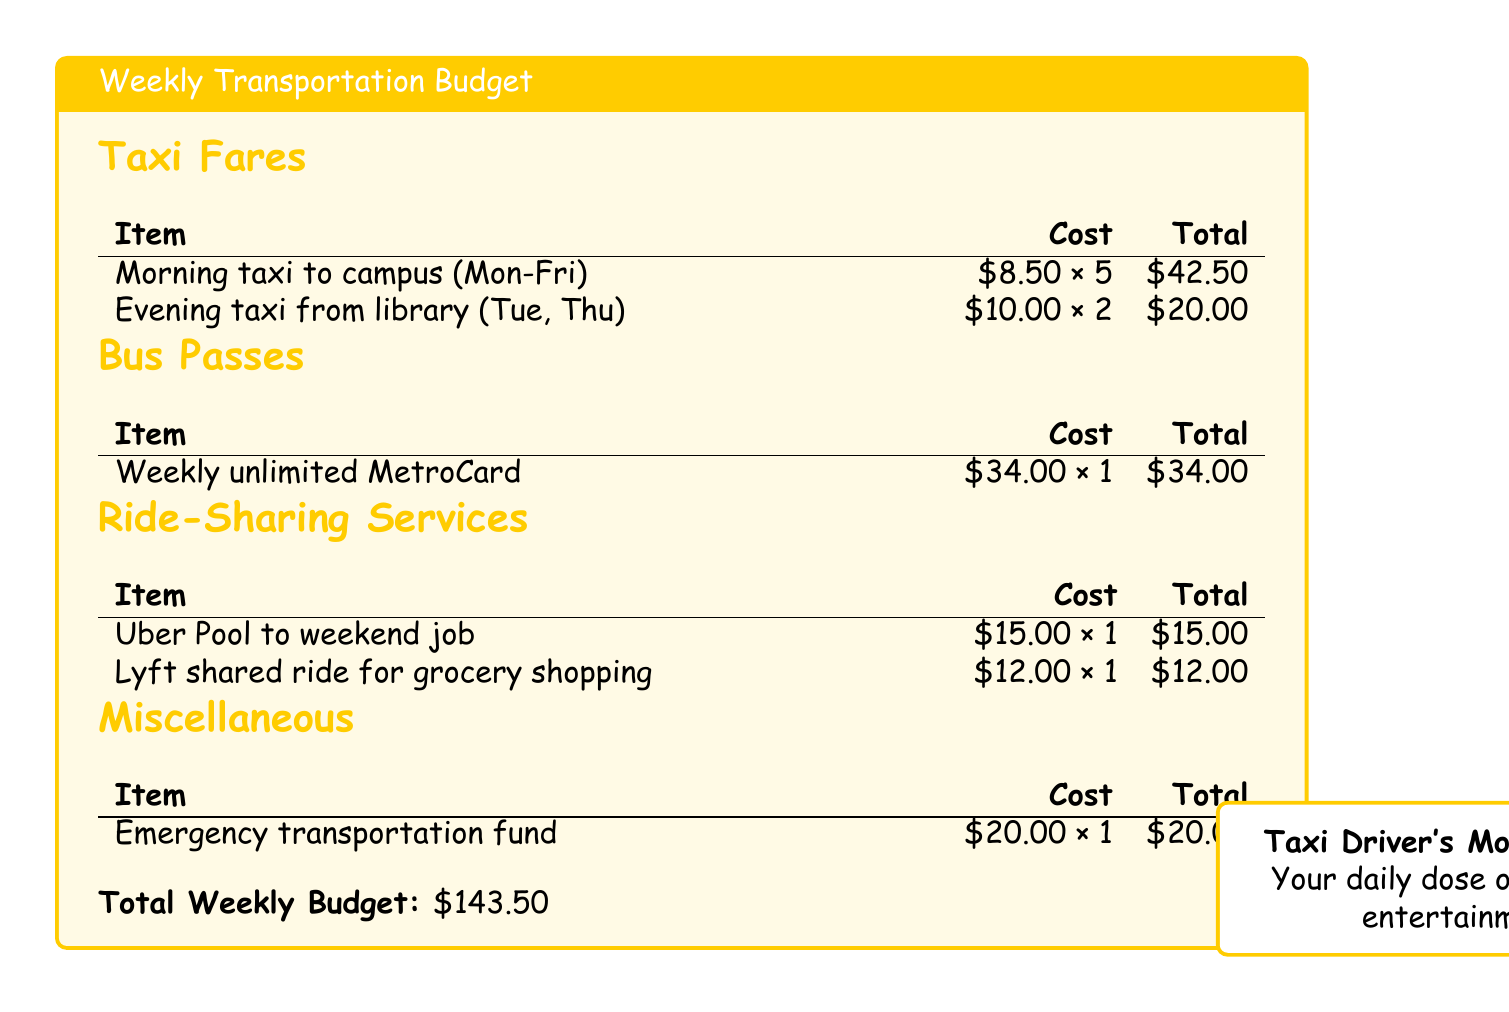What is the total cost for morning taxis to campus? The total cost for morning taxis is calculated as $8.50 multiplied by 5 days, which equals $42.50.
Answer: $42.50 What is the cost of the weekly unlimited MetroCard? The document states that the cost of the weekly unlimited MetroCard is $34.00.
Answer: $34.00 How much is spent on ride-sharing services? The total for ride-sharing services is the sum of $15.00 and $12.00, which is $27.00.
Answer: $27.00 What is the total weekly budget for transportation? The total weekly budget is indicated at the bottom of the document, which adds up to $143.50.
Answer: $143.50 How many rides are accounted for in the evening taxi section? The evening taxi section lists 2 rides, specifically on Tuesday and Thursday.
Answer: 2 What is the cost of the emergency transportation fund? The document specifies that the emergency transportation fund costs $20.00.
Answer: $20.00 What type of rides does the document specify for ride-sharing services? The ride-sharing services mentioned are Uber Pool and Lyft shared ride.
Answer: Uber Pool and Lyft shared ride How many taxis are taken in the evening from the library? The document shows that two taxi rides are taken from the library on Tuesday and Thursday evenings.
Answer: 2 What is the total amount spent on buses and taxis combined? The total amount spent on buses and taxis is $42.50 (taxis) + $34.00 (bus) = $76.50.
Answer: $76.50 